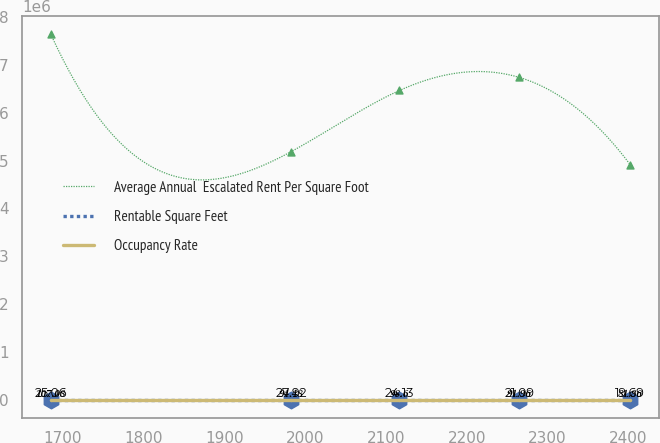Convert chart. <chart><loc_0><loc_0><loc_500><loc_500><line_chart><ecel><fcel>Average Annual  Escalated Rent Per Square Foot<fcel>Rentable Square Feet<fcel>Occupancy Rate<nl><fcel>1685.39<fcel>7.63982e+06<fcel>107.08<fcel>25.06<nl><fcel>1982.69<fcel>5.18871e+06<fcel>94.48<fcel>27.92<nl><fcel>2116.67<fcel>6.46803e+06<fcel>98.6<fcel>24.13<nl><fcel>2265.03<fcel>6.74038e+06<fcel>91.96<fcel>21.09<nl><fcel>2402.13<fcel>4.91636e+06<fcel>81.86<fcel>19.69<nl></chart> 